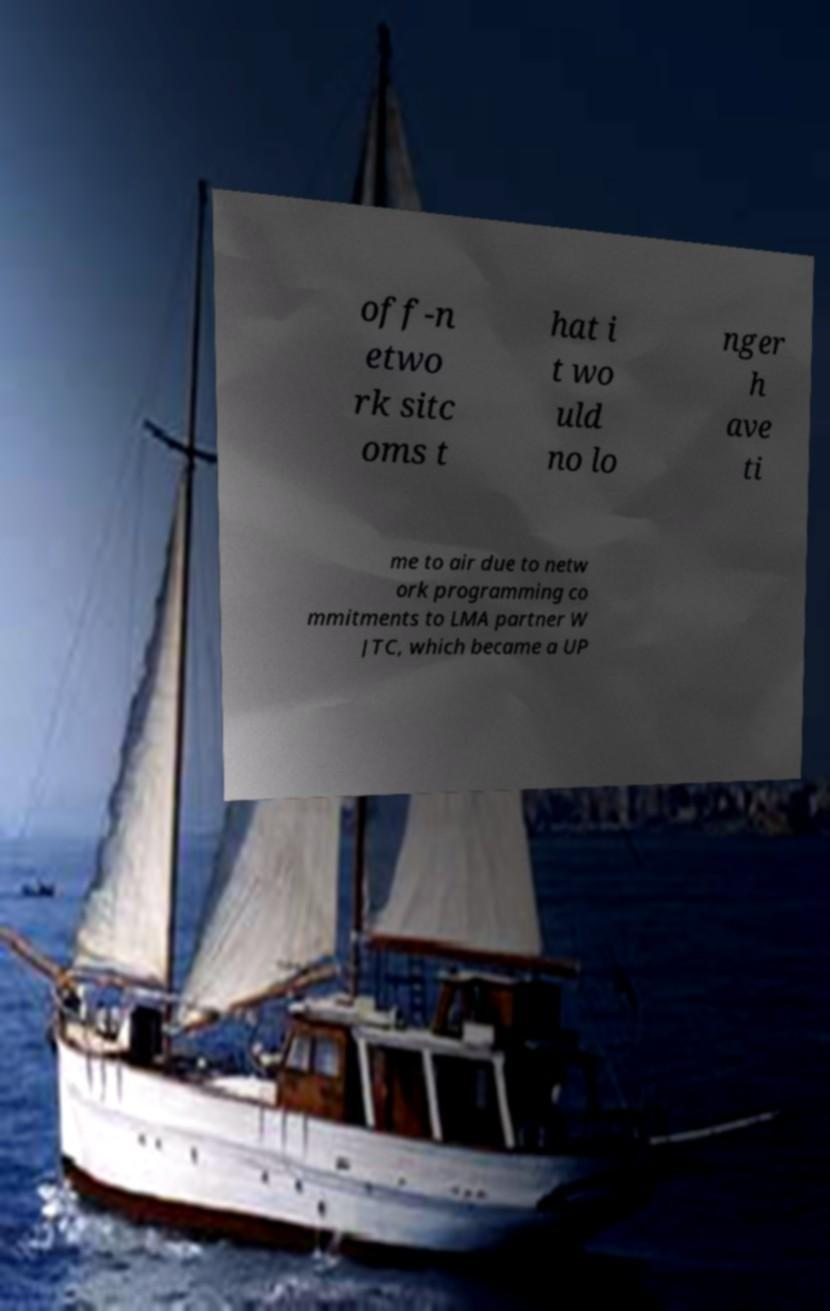Could you extract and type out the text from this image? off-n etwo rk sitc oms t hat i t wo uld no lo nger h ave ti me to air due to netw ork programming co mmitments to LMA partner W JTC, which became a UP 